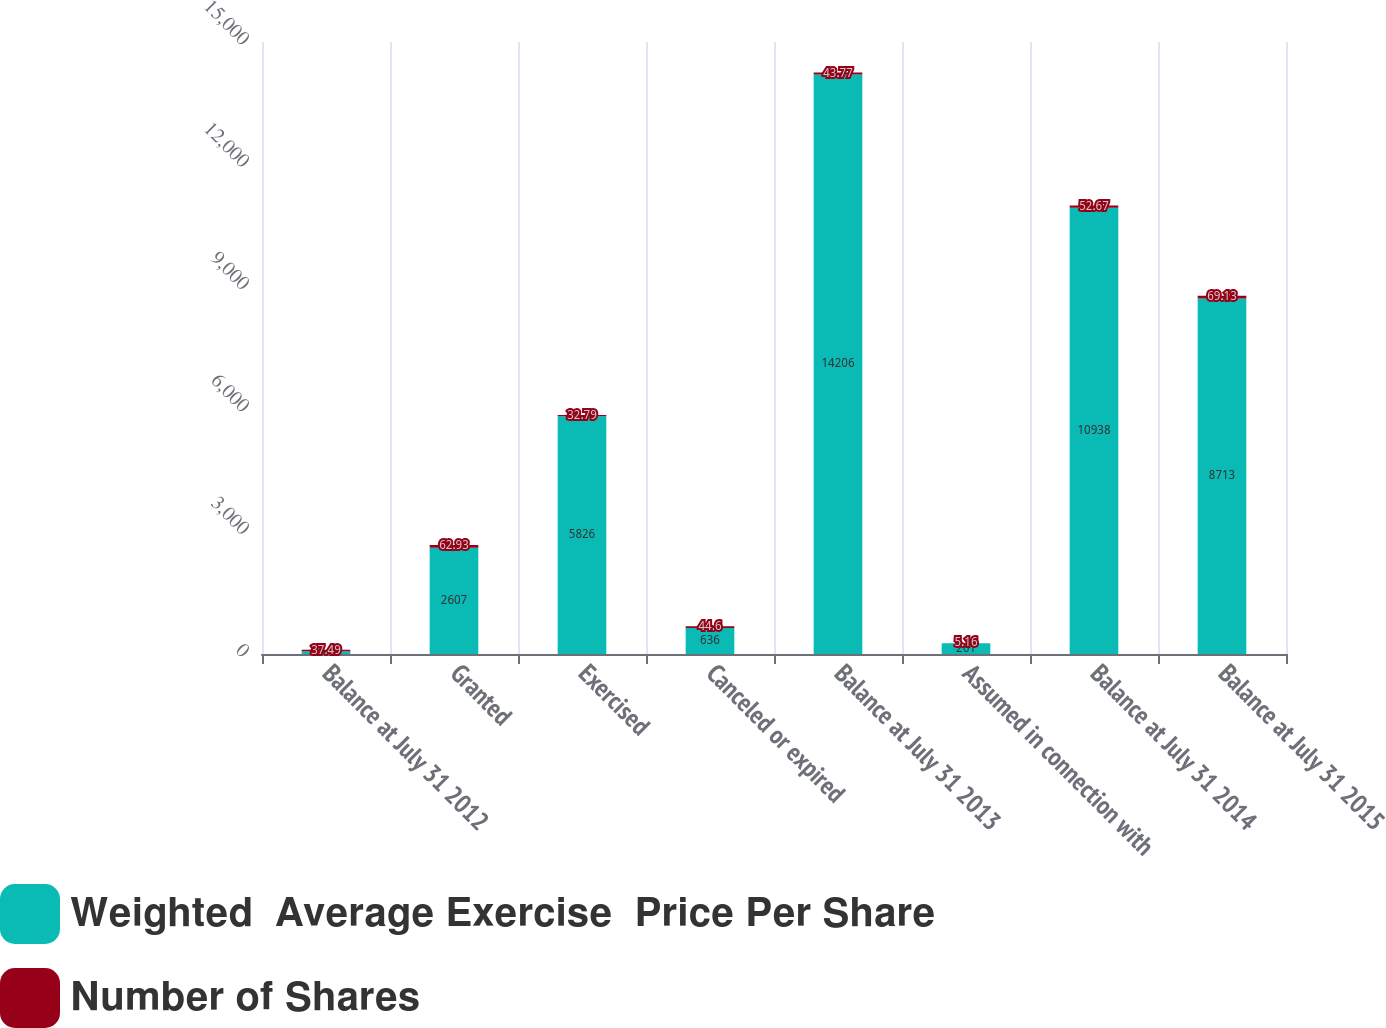<chart> <loc_0><loc_0><loc_500><loc_500><stacked_bar_chart><ecel><fcel>Balance at July 31 2012<fcel>Granted<fcel>Exercised<fcel>Canceled or expired<fcel>Balance at July 31 2013<fcel>Assumed in connection with<fcel>Balance at July 31 2014<fcel>Balance at July 31 2015<nl><fcel>Weighted  Average Exercise  Price Per Share<fcel>69.13<fcel>2607<fcel>5826<fcel>636<fcel>14206<fcel>261<fcel>10938<fcel>8713<nl><fcel>Number of Shares<fcel>37.49<fcel>62.93<fcel>32.79<fcel>44.6<fcel>43.77<fcel>5.16<fcel>52.67<fcel>69.13<nl></chart> 